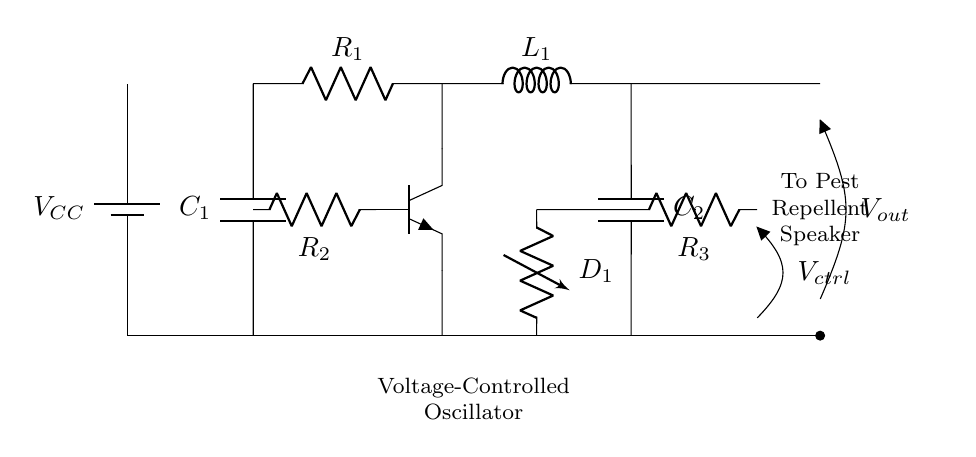What is the control voltage input in the circuit? The control voltage input is indicated as V_ctrl, which is represented as a voltage source connected to the circuit.
Answer: V_ctrl What type of transistor is used in the oscillator? The transistor is an npn type, which is shown in the diagram with the corresponding symbol.
Answer: npn What is the function of the varactor diode in this circuit? The varactor diode, labeled as D_1, is used to vary the capacitance based on the control voltage, which in turn affects the oscillation frequency.
Answer: Frequency modulation How many capacitors are present in the oscillator circuit? The schematic shows two capacitors labeled C_1 and C_2 connected in the circuit.
Answer: 2 What component is labeled as L_1 in the circuit? L_1 is the inductor, which plays a key role in determining the frequency of the oscillator by working with the capacitors.
Answer: Inductor What is the relationship between R_1 and C_1 in the context of oscillation? R_1 (a resistor) and C_1 (a capacitor) form an RC network that influences the time constant and thus the oscillation frequency.
Answer: Time constant What is the output voltage labeled as in the circuit? The output voltage is indicated as V_out, showing the output signal produced by the oscillator circuit.
Answer: V_out 